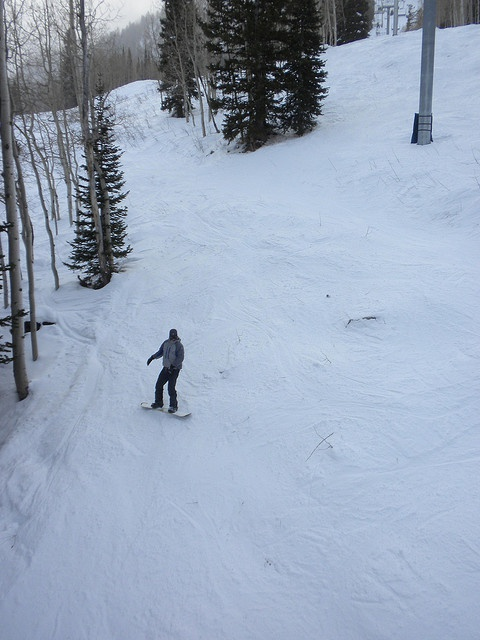Describe the objects in this image and their specific colors. I can see people in gray, black, and darkblue tones and snowboard in gray and darkgray tones in this image. 